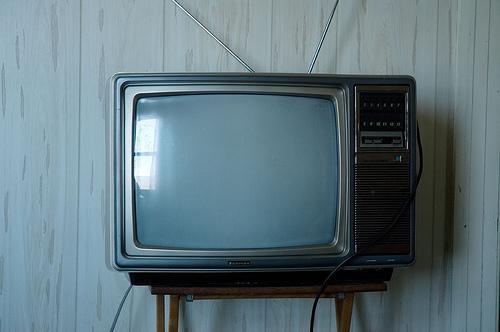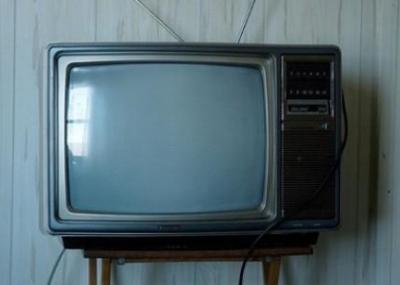The first image is the image on the left, the second image is the image on the right. Analyze the images presented: Is the assertion "At least one of the images shows a remote next to the TV." valid? Answer yes or no. No. 